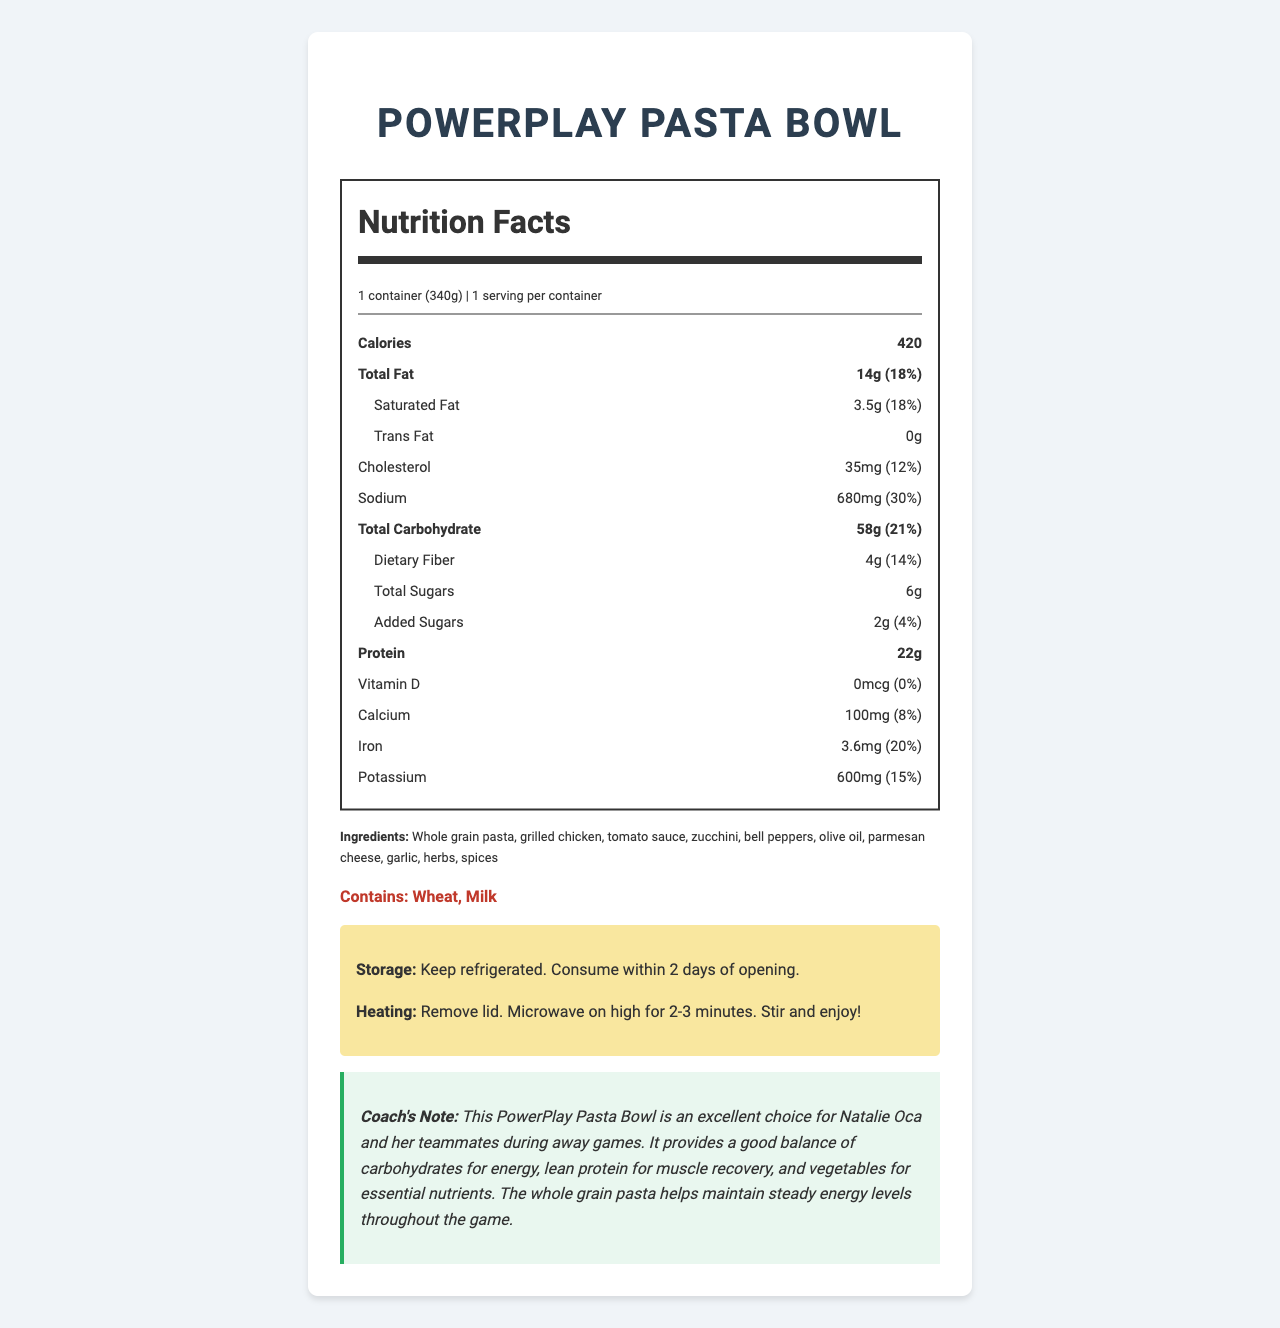what is the serving size of the PowerPlay Pasta Bowl? The serving size is specified at the beginning of the nutrition label under the product name.
Answer: 1 container (340g) how many calories does one serving of the PowerPlay Pasta Bowl contain? The number of calories is listed in the bold section of the nutrition facts.
Answer: 420 calories how much total fat is in the PowerPlay Pasta Bowl? The total fat content is listed in the bold section under the nutrition facts.
Answer: 14g what is the daily value percentage of iron in the PowerPlay Pasta Bowl? The iron content and its daily value percentage are listed in the nutrition facts.
Answer: 20% name the allergens mentioned in the PowerPlay Pasta Bowl? The allergens are listed in the "Contains" section within the document.
Answer: Wheat, Milk what nutrient has 0mcg in the PowerPlay Pasta Bowl? The amount of Vitamin D is listed as 0mcg in the nutrition facts.
Answer: Vitamin D which two nutrients have the same daily value percentage, and what is that percentage? A. Total Fat and Cholesterol B. Saturated Fat and Sodium C. Total Carbohydrate and Protein D. Total Fat and Saturated Fat Both Total Fat and Saturated Fat have a daily value percentage of 18%.
Answer: D. Total Fat and Saturated Fat how much added sugars are in the PowerPlay Pasta Bowl? A. 4g B. 2g C. 6g D. 0g The amount of added sugars is listed as 2g in the nutrition facts.
Answer: B. 2g is the PowerPlay Pasta Bowl a good source of dietary fiber? The dietary fiber content is 4g, which is 14% of the daily value, indicating it is a good source.
Answer: Yes summarize the main idea of the document. The document conveys comprehensive nutritional and preparatory information about a pre-packaged meal suitable for student-athletes, emphasizing its balanced nutrient content.
Answer: The document provides detailed nutritional information of the PowerPlay Pasta Bowl, which includes serving size, calorie content, nutrient breakdown, ingredients, allergens, storage, heating instructions, and a coach's note explaining its benefits for student-athletes. what is the advice for consuming the PowerPlay Pasta Bowl after opening? The storage instructions specify to keep the meal refrigerated and consume it within 2 days of opening.
Answer: Consume within 2 days of opening. how should the PowerPlay Pasta Bowl be heated? The heating instructions detail the steps for heating the meal in the microwave.
Answer: Remove lid. Microwave on high for 2-3 minutes. Stir and enjoy! is the PowerPlay Pasta Bowl suitable for someone with a milk allergy? The allergens section indicates that the meal contains milk, making it unsuitable for someone with a milk allergy.
Answer: No what whole grain source is included in the PowerPlay Pasta Bowl? The ingredients section lists whole grain pasta as part of the meal.
Answer: Whole grain pasta how many servings are in one container of the PowerPlay Pasta Bowl? The "servings per container" information states that one container equals one serving.
Answer: 1 serving does the nutrition label provide information about vitamin C content? The document does not mention vitamin C, so its content cannot be determined.
Answer: Not enough information 